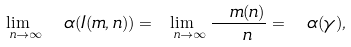Convert formula to latex. <formula><loc_0><loc_0><loc_500><loc_500>\lim _ { \ n \rightarrow \infty } { \ \alpha ( I ( m , n ) ) } = \lim _ { \ n \rightarrow \infty } \frac { \ m ( n ) } { \ n } = { \ \alpha ( \gamma ) , \ }</formula> 